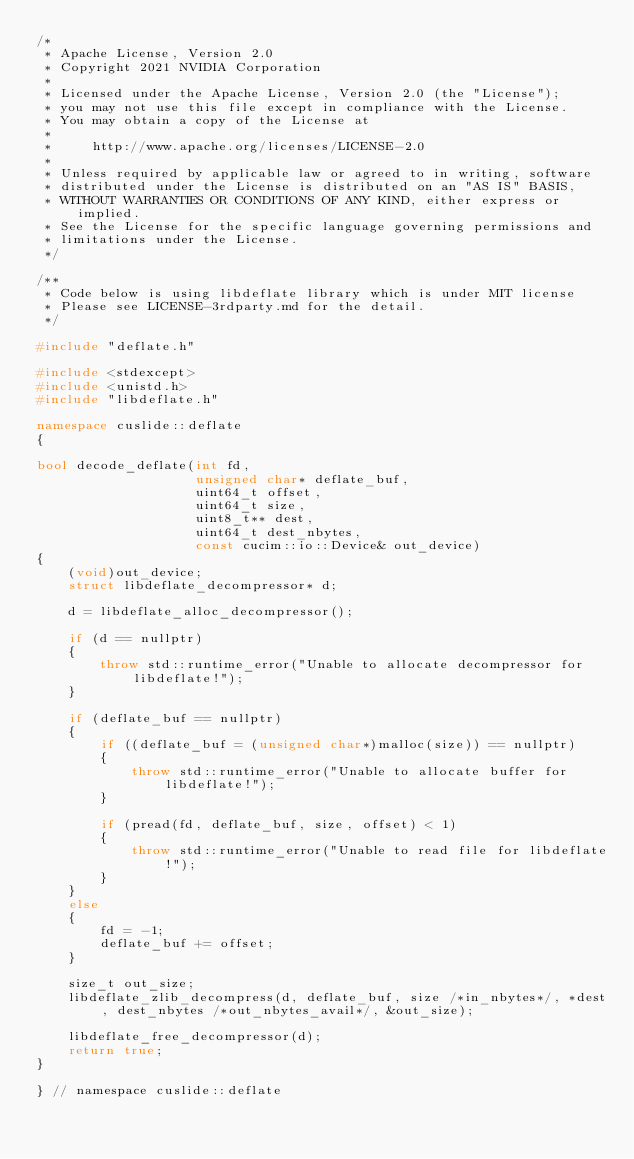<code> <loc_0><loc_0><loc_500><loc_500><_C++_>/*
 * Apache License, Version 2.0
 * Copyright 2021 NVIDIA Corporation
 *
 * Licensed under the Apache License, Version 2.0 (the "License");
 * you may not use this file except in compliance with the License.
 * You may obtain a copy of the License at
 *
 *     http://www.apache.org/licenses/LICENSE-2.0
 *
 * Unless required by applicable law or agreed to in writing, software
 * distributed under the License is distributed on an "AS IS" BASIS,
 * WITHOUT WARRANTIES OR CONDITIONS OF ANY KIND, either express or implied.
 * See the License for the specific language governing permissions and
 * limitations under the License.
 */

/**
 * Code below is using libdeflate library which is under MIT license
 * Please see LICENSE-3rdparty.md for the detail.
 */

#include "deflate.h"

#include <stdexcept>
#include <unistd.h>
#include "libdeflate.h"

namespace cuslide::deflate
{

bool decode_deflate(int fd,
                    unsigned char* deflate_buf,
                    uint64_t offset,
                    uint64_t size,
                    uint8_t** dest,
                    uint64_t dest_nbytes,
                    const cucim::io::Device& out_device)
{
    (void)out_device;
    struct libdeflate_decompressor* d;

    d = libdeflate_alloc_decompressor();

    if (d == nullptr)
    {
        throw std::runtime_error("Unable to allocate decompressor for libdeflate!");
    }

    if (deflate_buf == nullptr)
    {
        if ((deflate_buf = (unsigned char*)malloc(size)) == nullptr)
        {
            throw std::runtime_error("Unable to allocate buffer for libdeflate!");
        }

        if (pread(fd, deflate_buf, size, offset) < 1)
        {
            throw std::runtime_error("Unable to read file for libdeflate!");
        }
    }
    else
    {
        fd = -1;
        deflate_buf += offset;
    }

    size_t out_size;
    libdeflate_zlib_decompress(d, deflate_buf, size /*in_nbytes*/, *dest, dest_nbytes /*out_nbytes_avail*/, &out_size);

    libdeflate_free_decompressor(d);
    return true;
}

} // namespace cuslide::deflate
</code> 